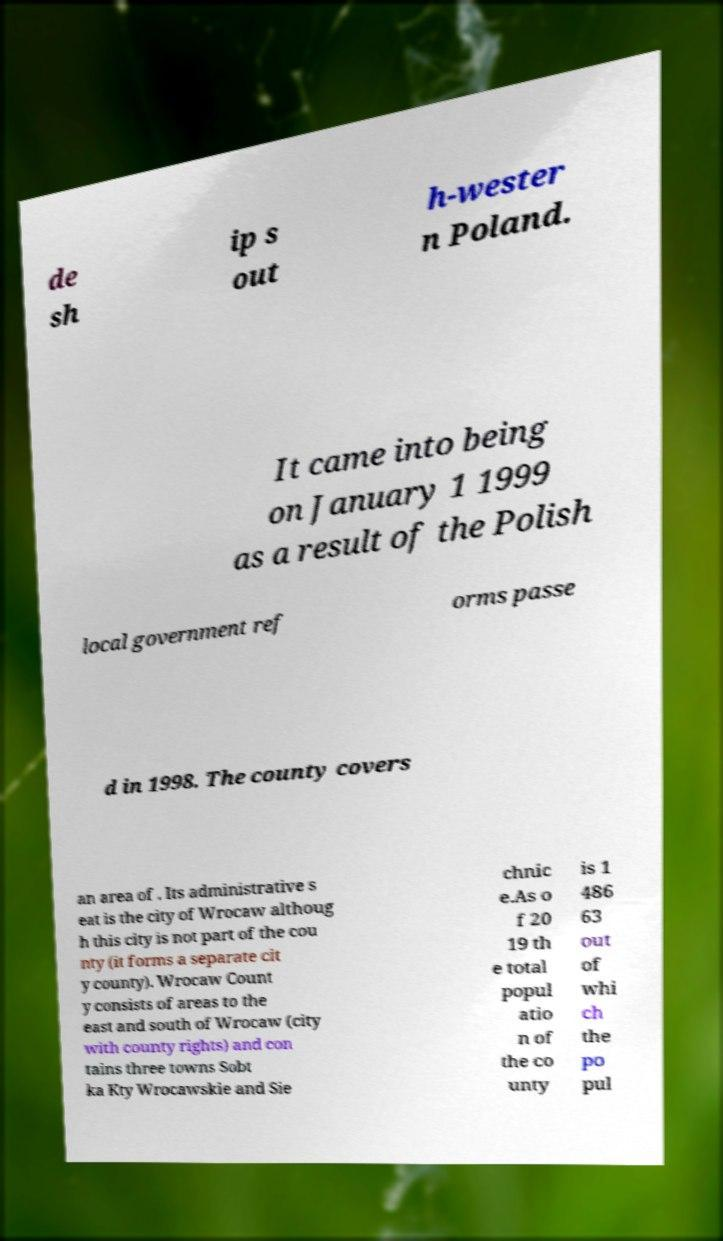Please read and relay the text visible in this image. What does it say? de sh ip s out h-wester n Poland. It came into being on January 1 1999 as a result of the Polish local government ref orms passe d in 1998. The county covers an area of . Its administrative s eat is the city of Wrocaw althoug h this city is not part of the cou nty (it forms a separate cit y county). Wrocaw Count y consists of areas to the east and south of Wrocaw (city with county rights) and con tains three towns Sobt ka Kty Wrocawskie and Sie chnic e.As o f 20 19 th e total popul atio n of the co unty is 1 486 63 out of whi ch the po pul 